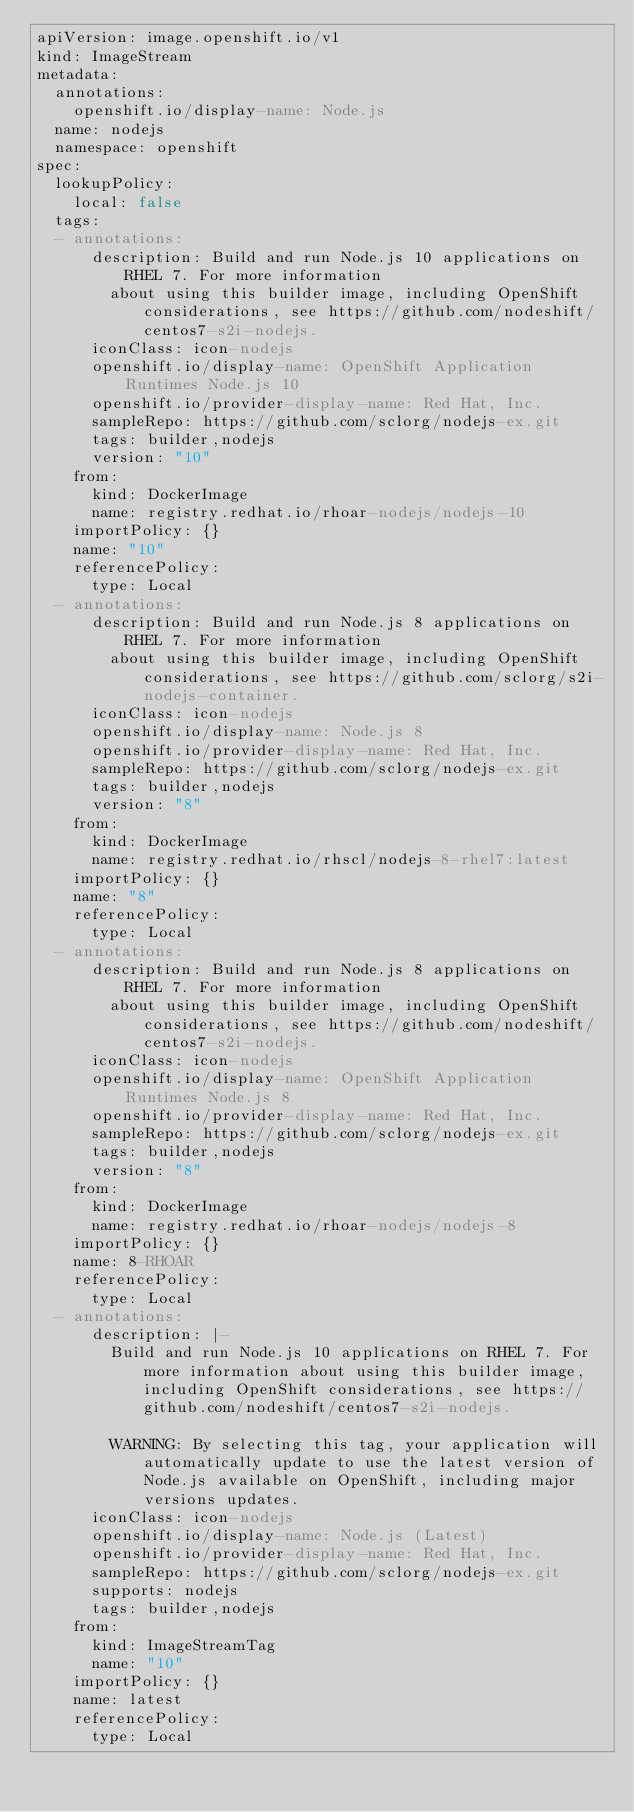<code> <loc_0><loc_0><loc_500><loc_500><_YAML_>apiVersion: image.openshift.io/v1
kind: ImageStream
metadata:
  annotations:
    openshift.io/display-name: Node.js
  name: nodejs
  namespace: openshift
spec:
  lookupPolicy:
    local: false
  tags:
  - annotations:
      description: Build and run Node.js 10 applications on RHEL 7. For more information
        about using this builder image, including OpenShift considerations, see https://github.com/nodeshift/centos7-s2i-nodejs.
      iconClass: icon-nodejs
      openshift.io/display-name: OpenShift Application Runtimes Node.js 10
      openshift.io/provider-display-name: Red Hat, Inc.
      sampleRepo: https://github.com/sclorg/nodejs-ex.git
      tags: builder,nodejs
      version: "10"
    from:
      kind: DockerImage
      name: registry.redhat.io/rhoar-nodejs/nodejs-10
    importPolicy: {}
    name: "10"
    referencePolicy:
      type: Local
  - annotations:
      description: Build and run Node.js 8 applications on RHEL 7. For more information
        about using this builder image, including OpenShift considerations, see https://github.com/sclorg/s2i-nodejs-container.
      iconClass: icon-nodejs
      openshift.io/display-name: Node.js 8
      openshift.io/provider-display-name: Red Hat, Inc.
      sampleRepo: https://github.com/sclorg/nodejs-ex.git
      tags: builder,nodejs
      version: "8"
    from:
      kind: DockerImage
      name: registry.redhat.io/rhscl/nodejs-8-rhel7:latest
    importPolicy: {}
    name: "8"
    referencePolicy:
      type: Local
  - annotations:
      description: Build and run Node.js 8 applications on RHEL 7. For more information
        about using this builder image, including OpenShift considerations, see https://github.com/nodeshift/centos7-s2i-nodejs.
      iconClass: icon-nodejs
      openshift.io/display-name: OpenShift Application Runtimes Node.js 8
      openshift.io/provider-display-name: Red Hat, Inc.
      sampleRepo: https://github.com/sclorg/nodejs-ex.git
      tags: builder,nodejs
      version: "8"
    from:
      kind: DockerImage
      name: registry.redhat.io/rhoar-nodejs/nodejs-8
    importPolicy: {}
    name: 8-RHOAR
    referencePolicy:
      type: Local
  - annotations:
      description: |-
        Build and run Node.js 10 applications on RHEL 7. For more information about using this builder image, including OpenShift considerations, see https://github.com/nodeshift/centos7-s2i-nodejs.

        WARNING: By selecting this tag, your application will automatically update to use the latest version of Node.js available on OpenShift, including major versions updates.
      iconClass: icon-nodejs
      openshift.io/display-name: Node.js (Latest)
      openshift.io/provider-display-name: Red Hat, Inc.
      sampleRepo: https://github.com/sclorg/nodejs-ex.git
      supports: nodejs
      tags: builder,nodejs
    from:
      kind: ImageStreamTag
      name: "10"
    importPolicy: {}
    name: latest
    referencePolicy:
      type: Local
</code> 